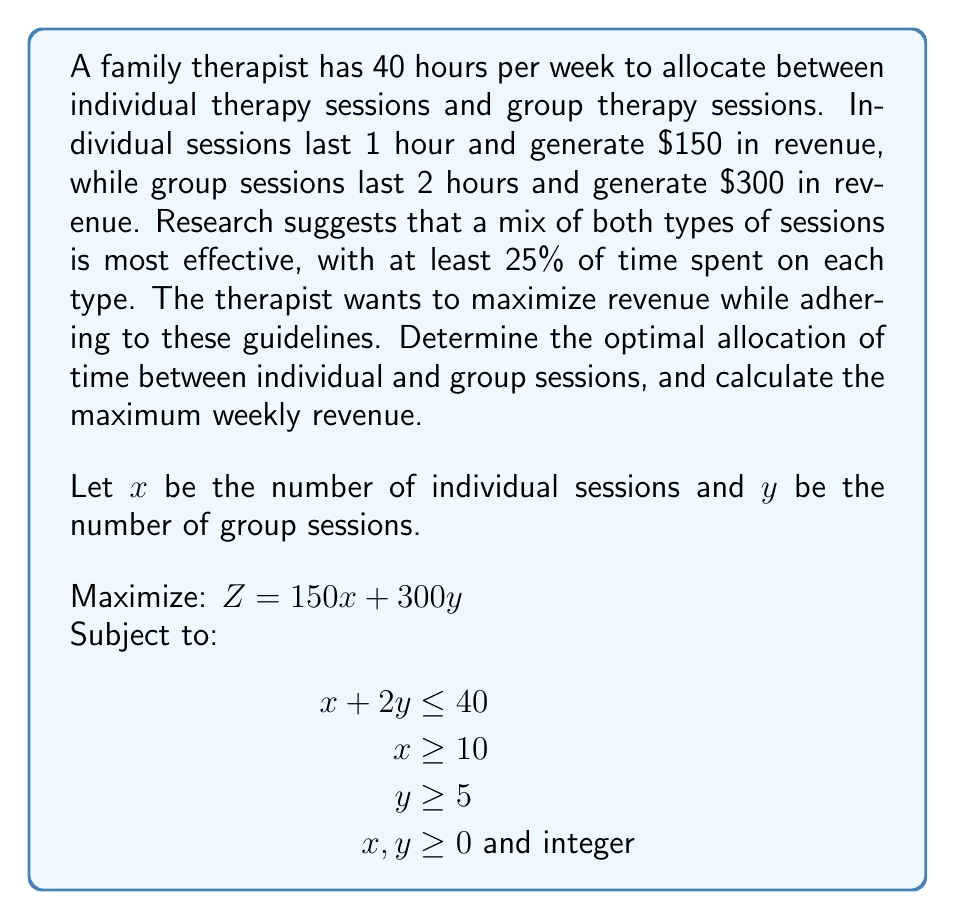What is the answer to this math problem? To solve this linear programming problem with integer constraints, we'll use the following steps:

1) First, let's graph the feasible region based on the constraints:

   $x + 2y \leq 40$ (time constraint)
   $x \geq 10$ (minimum 25% individual sessions)
   $y \geq 5$ (minimum 25% group sessions)
   $x, y \geq 0$ and integer

2) The vertices of the feasible region are:
   (10, 15), (30, 5), (10, 5)

3) We evaluate the objective function $Z = 150x + 300y$ at each vertex:

   At (10, 15): $Z = 150(10) + 300(15) = 6,000$
   At (30, 5):  $Z = 150(30) + 300(5)  = 6,000$
   At (10, 5):  $Z = 150(10) + 300(5)  = 3,000$

4) The maximum value occurs at both (10, 15) and (30, 5), giving a revenue of $6,000.

5) However, we need to check if there are any integer points inside the feasible region that give a higher value. The line connecting (10, 15) and (30, 5) is described by:

   $y = -0.5x + 20$

6) We can check integer points along this line:
   (11, 14.5), (12, 14), (13, 13.5), ..., (29, 5.5)

7) The best integer solution is (20, 10), which gives:

   $Z = 150(20) + 300(10) = 6,000$

This solution also satisfies all constraints:
20 + 2(10) = 40 hours
20 > 10 (minimum individual sessions)
10 > 5 (minimum group sessions)
Answer: The optimal allocation is 20 individual sessions and 10 group sessions per week, generating a maximum weekly revenue of $6,000. 